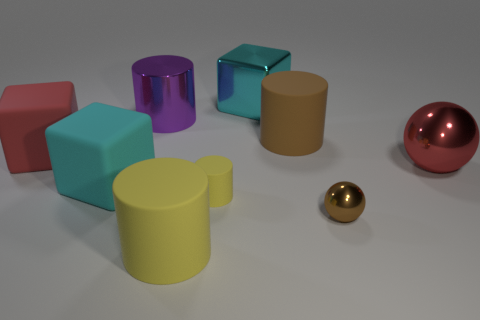Subtract 1 cylinders. How many cylinders are left? 3 Add 1 yellow cylinders. How many objects exist? 10 Subtract all cylinders. How many objects are left? 5 Add 2 red balls. How many red balls are left? 3 Add 9 small brown metal things. How many small brown metal things exist? 10 Subtract 0 blue balls. How many objects are left? 9 Subtract all green shiny cylinders. Subtract all big yellow matte cylinders. How many objects are left? 8 